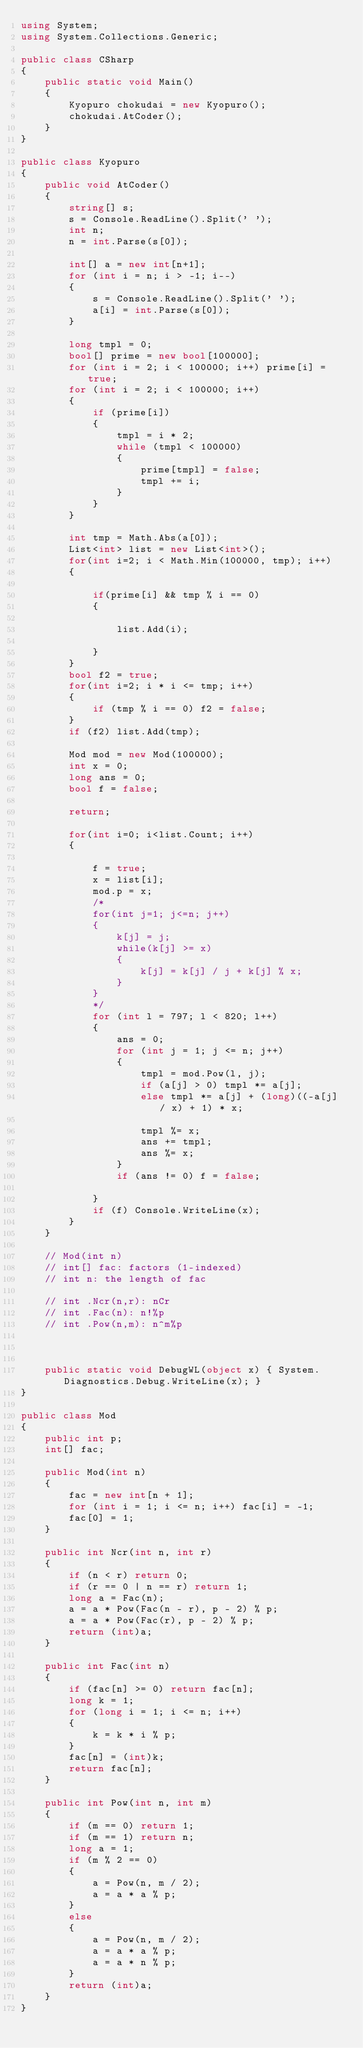<code> <loc_0><loc_0><loc_500><loc_500><_C#_>using System;
using System.Collections.Generic;

public class CSharp
{
    public static void Main()
    {
        Kyopuro chokudai = new Kyopuro();
        chokudai.AtCoder();
    }
}

public class Kyopuro
{
    public void AtCoder()
    {
        string[] s;
        s = Console.ReadLine().Split(' ');
        int n;
        n = int.Parse(s[0]);

        int[] a = new int[n+1];
        for (int i = n; i > -1; i--)
        {
            s = Console.ReadLine().Split(' ');
            a[i] = int.Parse(s[0]);
        }

        long tmpl = 0;
        bool[] prime = new bool[100000];
        for (int i = 2; i < 100000; i++) prime[i] = true;
        for (int i = 2; i < 100000; i++)
        {
            if (prime[i])
            {
                tmpl = i * 2;
                while (tmpl < 100000)
                {
                    prime[tmpl] = false;
                    tmpl += i;
                }
            }
        }

        int tmp = Math.Abs(a[0]);
        List<int> list = new List<int>();
        for(int i=2; i < Math.Min(100000, tmp); i++)
        {

            if(prime[i] && tmp % i == 0)
            {

                list.Add(i);
                
            }
        }
        bool f2 = true;
        for(int i=2; i * i <= tmp; i++)
        {
            if (tmp % i == 0) f2 = false;
        }
        if (f2) list.Add(tmp);

        Mod mod = new Mod(100000);
        int x = 0;
        long ans = 0;
        bool f = false;

        return;

        for(int i=0; i<list.Count; i++)
        {
            
            f = true;
            x = list[i];
            mod.p = x;
            /*
            for(int j=1; j<=n; j++)
            {
                k[j] = j;
                while(k[j] >= x)
                {
                    k[j] = k[j] / j + k[j] % x;
                }
            }
            */
            for (int l = 797; l < 820; l++)
            {
                ans = 0;
                for (int j = 1; j <= n; j++)
                {
                    tmpl = mod.Pow(l, j);
                    if (a[j] > 0) tmpl *= a[j];
                    else tmpl *= a[j] + (long)((-a[j] / x) + 1) * x;
                    
                    tmpl %= x;
                    ans += tmpl;
                    ans %= x;                                
                }
                if (ans != 0) f = false;
                
            }
            if (f) Console.WriteLine(x);
        }
    }

    // Mod(int n)
    // int[] fac: factors (1-indexed)
    // int n: the length of fac

    // int .Ncr(n,r): nCr
    // int .Fac(n): n!%p
    // int .Pow(n,m): n^m%p

    

    public static void DebugWL(object x) { System.Diagnostics.Debug.WriteLine(x); }
}

public class Mod
{
    public int p;
    int[] fac;

    public Mod(int n)
    {
        fac = new int[n + 1];
        for (int i = 1; i <= n; i++) fac[i] = -1;
        fac[0] = 1;
    }

    public int Ncr(int n, int r)
    {
        if (n < r) return 0;
        if (r == 0 | n == r) return 1;
        long a = Fac(n);
        a = a * Pow(Fac(n - r), p - 2) % p;
        a = a * Pow(Fac(r), p - 2) % p;
        return (int)a;
    }

    public int Fac(int n)
    {
        if (fac[n] >= 0) return fac[n];
        long k = 1;
        for (long i = 1; i <= n; i++)
        {
            k = k * i % p;
        }
        fac[n] = (int)k;
        return fac[n];
    }

    public int Pow(int n, int m)
    {
        if (m == 0) return 1;
        if (m == 1) return n;
        long a = 1;
        if (m % 2 == 0)
        {
            a = Pow(n, m / 2);
            a = a * a % p;
        }
        else
        {
            a = Pow(n, m / 2);
            a = a * a % p;
            a = a * n % p;
        }
        return (int)a;
    }
}
</code> 